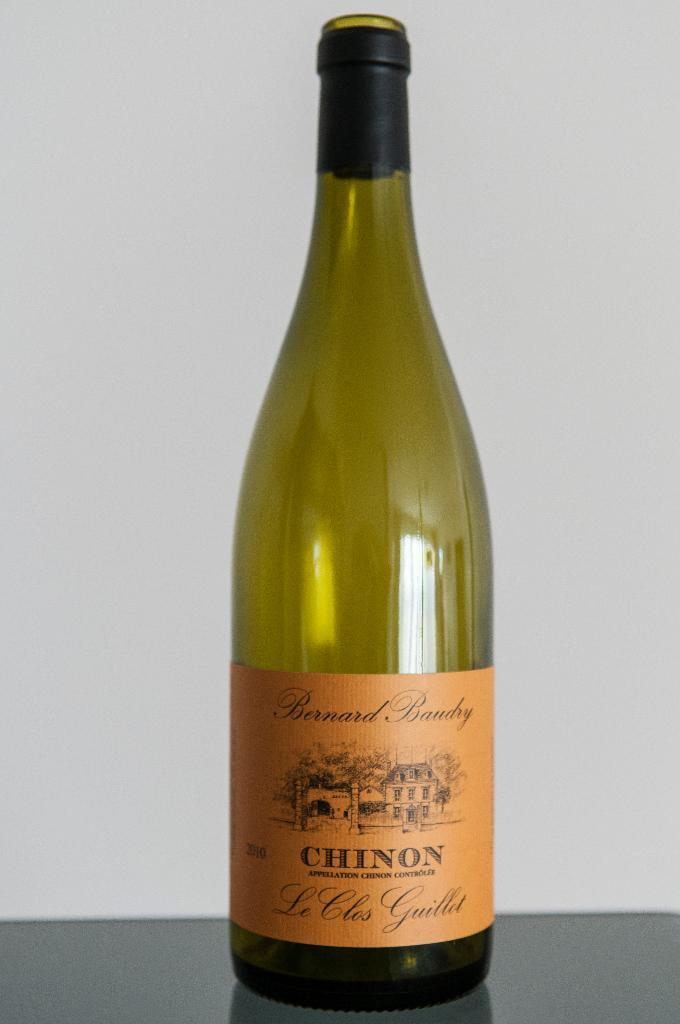<image>
Provide a brief description of the given image. An empty bottled of chinon branded white wine. 